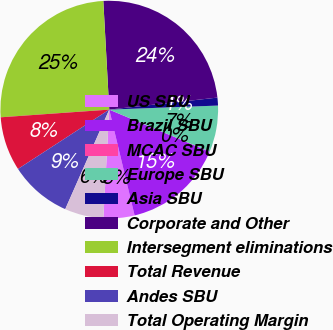Convert chart. <chart><loc_0><loc_0><loc_500><loc_500><pie_chart><fcel>US SBU<fcel>Brazil SBU<fcel>MCAC SBU<fcel>Europe SBU<fcel>Asia SBU<fcel>Corporate and Other<fcel>Intersegment eliminations<fcel>Total Revenue<fcel>Andes SBU<fcel>Total Operating Margin<nl><fcel>4.61%<fcel>14.93%<fcel>0.02%<fcel>6.9%<fcel>1.17%<fcel>24.11%<fcel>25.26%<fcel>8.05%<fcel>9.2%<fcel>5.76%<nl></chart> 